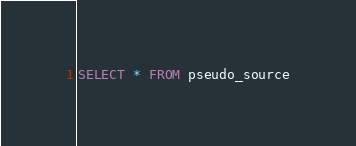Convert code to text. <code><loc_0><loc_0><loc_500><loc_500><_SQL_>SELECT * FROM pseudo_source</code> 